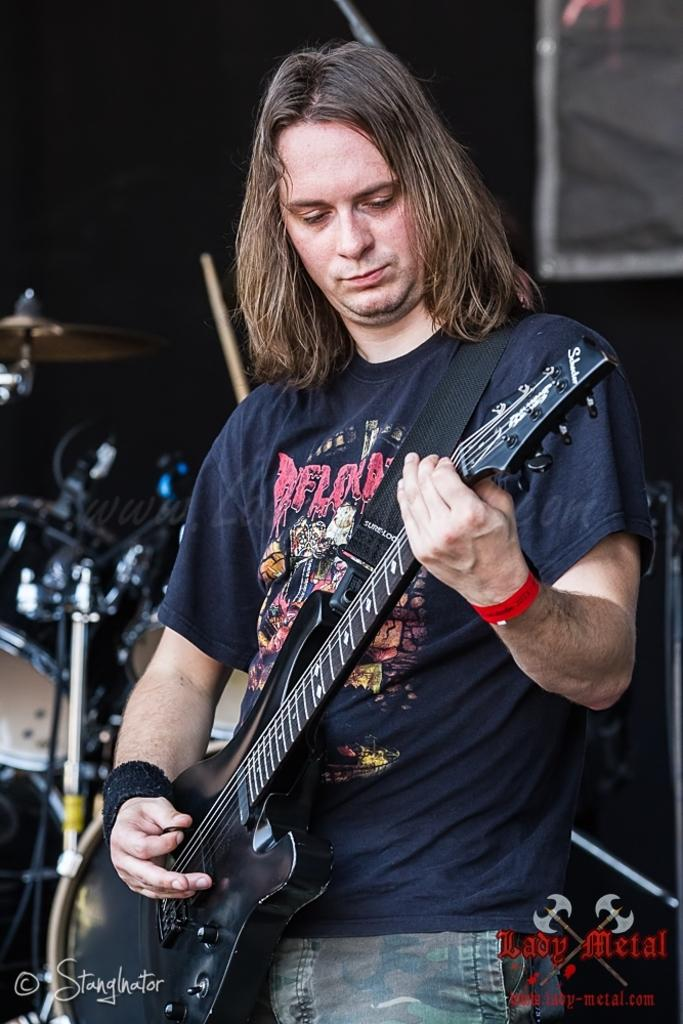What is the main subject of the image? The main subject of the image is a guy. Can you describe the guy's appearance? The guy has short hair. What is the guy holding in the image? The guy is holding a guitar. What is the guy doing with the guitar? The guy is playing the guitar. Are there any accessories visible on the guy's hands? Yes, the guy has a red color band on his left hand and a black color band on his right hand. What type of spoon can be seen in the guy's hand while playing the guitar? There is no spoon present in the image; the guy is holding a guitar and has color bands on his hands. Can you see any wings on the guy while he is playing the guitar? There are no wings visible on the guy in the image; he is simply playing the guitar with color bands on his hands. 